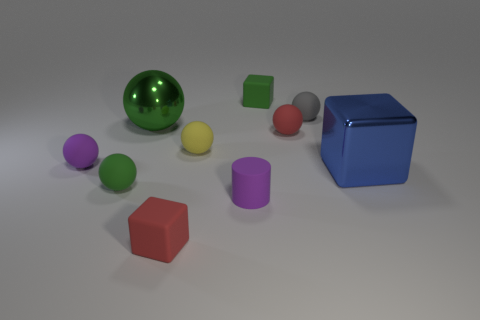Subtract all red cylinders. How many green spheres are left? 2 Subtract all yellow balls. How many balls are left? 5 Subtract all green matte balls. How many balls are left? 5 Subtract 1 blocks. How many blocks are left? 2 Subtract all red spheres. Subtract all yellow blocks. How many spheres are left? 5 Subtract all balls. How many objects are left? 4 Subtract 0 brown blocks. How many objects are left? 10 Subtract all tiny yellow rubber balls. Subtract all red rubber things. How many objects are left? 7 Add 4 yellow rubber spheres. How many yellow rubber spheres are left? 5 Add 8 tiny green rubber things. How many tiny green rubber things exist? 10 